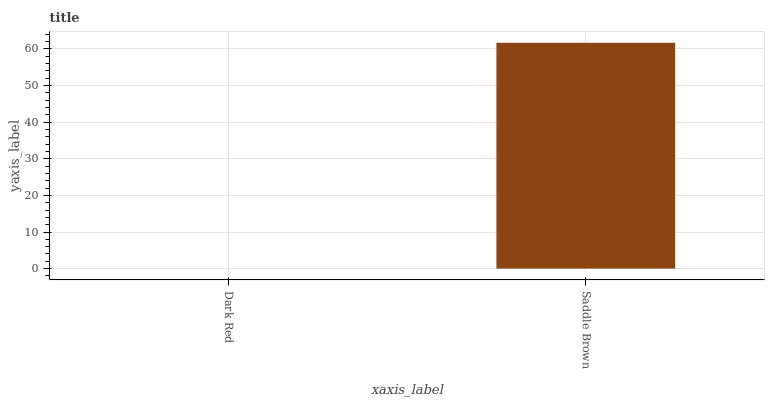Is Dark Red the minimum?
Answer yes or no. Yes. Is Saddle Brown the maximum?
Answer yes or no. Yes. Is Saddle Brown the minimum?
Answer yes or no. No. Is Saddle Brown greater than Dark Red?
Answer yes or no. Yes. Is Dark Red less than Saddle Brown?
Answer yes or no. Yes. Is Dark Red greater than Saddle Brown?
Answer yes or no. No. Is Saddle Brown less than Dark Red?
Answer yes or no. No. Is Saddle Brown the high median?
Answer yes or no. Yes. Is Dark Red the low median?
Answer yes or no. Yes. Is Dark Red the high median?
Answer yes or no. No. Is Saddle Brown the low median?
Answer yes or no. No. 